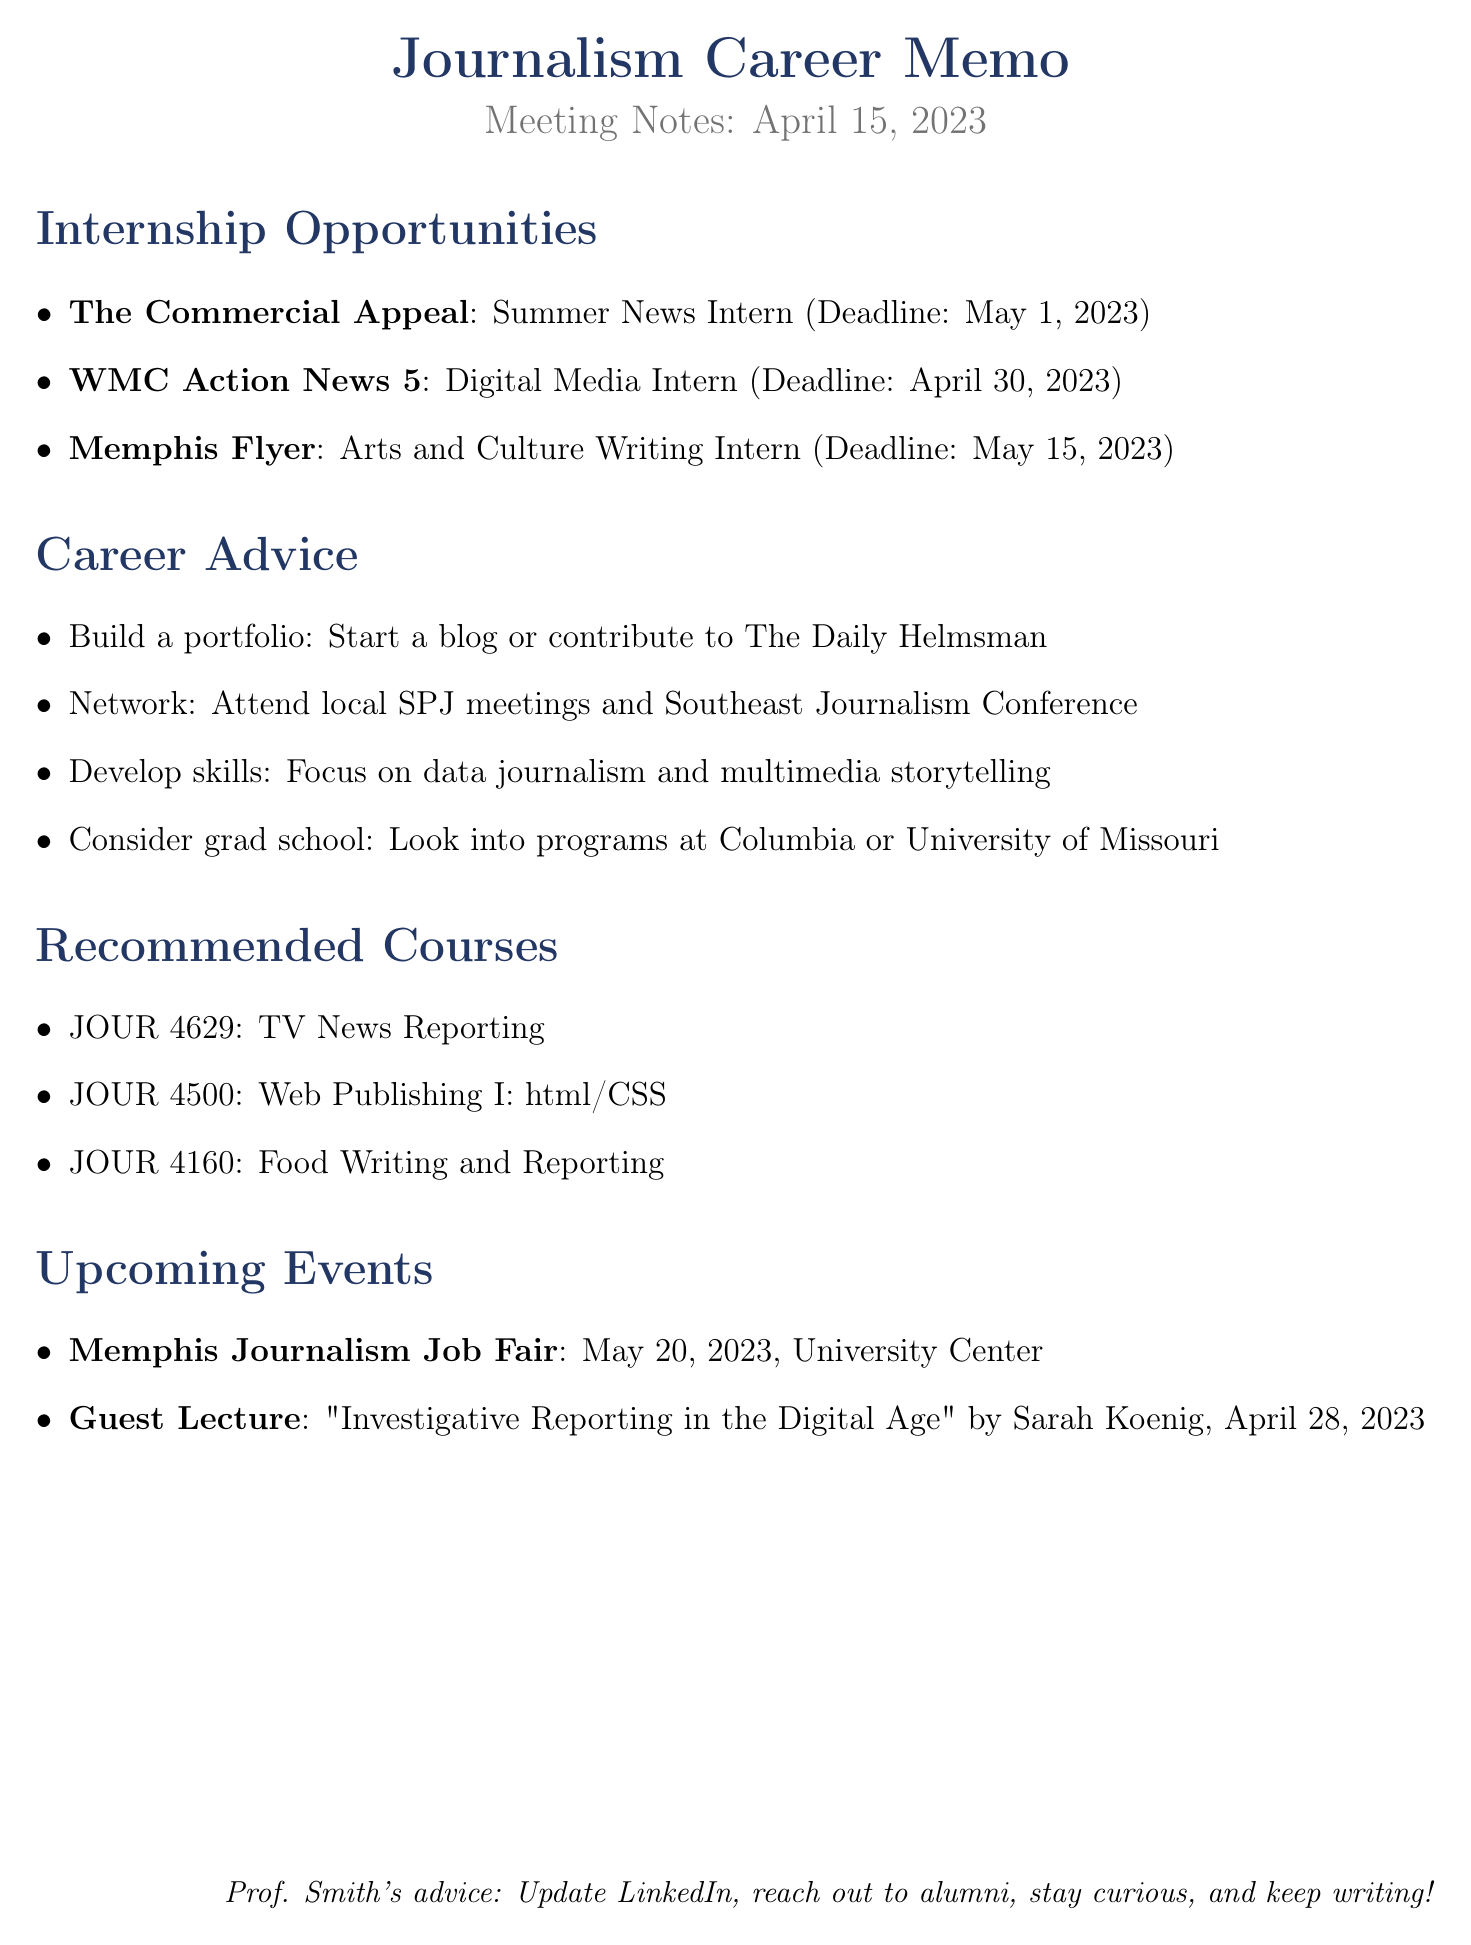what is the date of the meeting? The date of the meeting is explicitly stated in the document.
Answer: April 15, 2023 who is the professor mentioned in the meeting notes? The professor's name appears in the meeting details section of the document.
Answer: Professor Jane Smith what is the deadline for the Digital Media Intern position? The document lists specific deadlines for each internship opportunity.
Answer: April 30, 2023 which organization offers the internship position for Arts and Culture Writing? The organization offering this position is directly mentioned in the internship opportunities section.
Answer: Memphis Flyer what is one recommended skill to focus on according to the career advice? The career advice section provides various suggestions including specific skills for students.
Answer: data journalism how many upcoming events are listed in the document? The document includes a section for upcoming events, and the number can be counted directly.
Answer: 2 what course must be taken to learn about web publishing? The document specifies particular courses and their codes related to different topics, including web publishing.
Answer: Web Publishing I: html/CSS what is the location of the Memphis Journalism Job Fair? The document provides the venue for this specific event as part of the upcoming events section.
Answer: University Center, University of Memphis what is the advice given regarding LinkedIn? This advice is part of the professor's closing remarks in the document.
Answer: Update your LinkedIn profile 